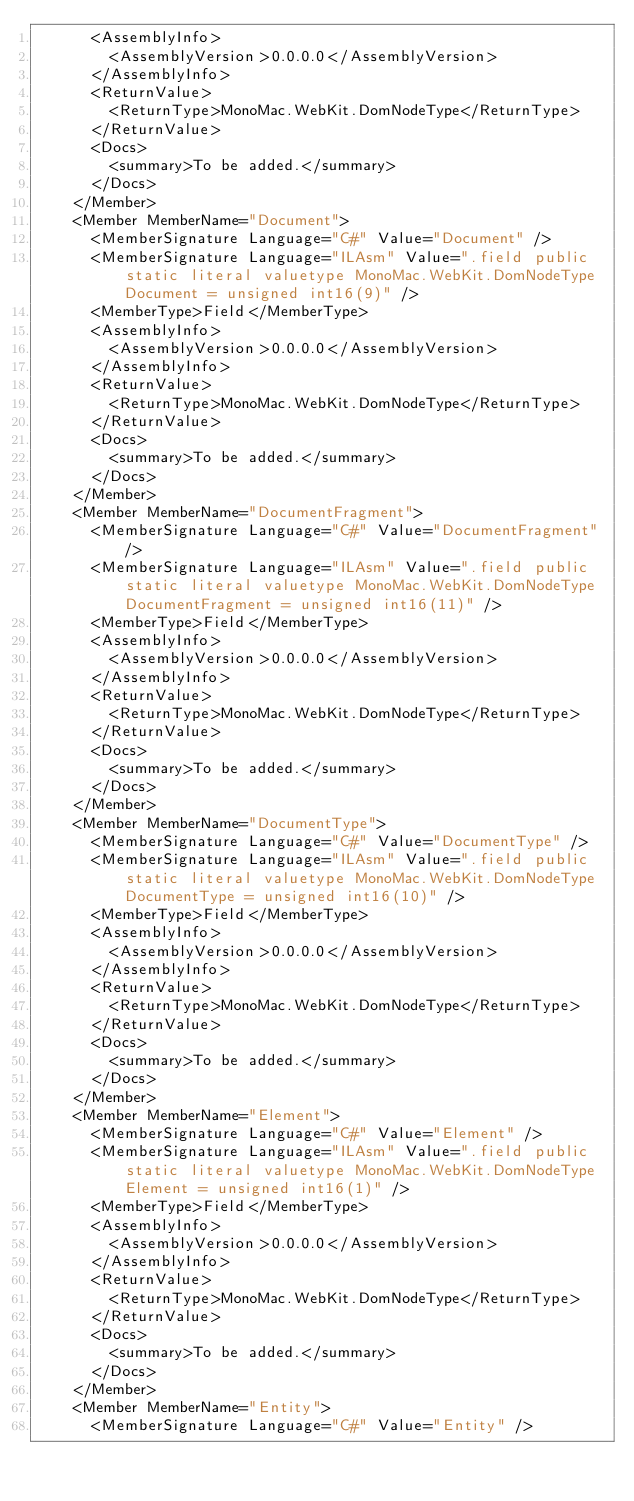<code> <loc_0><loc_0><loc_500><loc_500><_XML_>      <AssemblyInfo>
        <AssemblyVersion>0.0.0.0</AssemblyVersion>
      </AssemblyInfo>
      <ReturnValue>
        <ReturnType>MonoMac.WebKit.DomNodeType</ReturnType>
      </ReturnValue>
      <Docs>
        <summary>To be added.</summary>
      </Docs>
    </Member>
    <Member MemberName="Document">
      <MemberSignature Language="C#" Value="Document" />
      <MemberSignature Language="ILAsm" Value=".field public static literal valuetype MonoMac.WebKit.DomNodeType Document = unsigned int16(9)" />
      <MemberType>Field</MemberType>
      <AssemblyInfo>
        <AssemblyVersion>0.0.0.0</AssemblyVersion>
      </AssemblyInfo>
      <ReturnValue>
        <ReturnType>MonoMac.WebKit.DomNodeType</ReturnType>
      </ReturnValue>
      <Docs>
        <summary>To be added.</summary>
      </Docs>
    </Member>
    <Member MemberName="DocumentFragment">
      <MemberSignature Language="C#" Value="DocumentFragment" />
      <MemberSignature Language="ILAsm" Value=".field public static literal valuetype MonoMac.WebKit.DomNodeType DocumentFragment = unsigned int16(11)" />
      <MemberType>Field</MemberType>
      <AssemblyInfo>
        <AssemblyVersion>0.0.0.0</AssemblyVersion>
      </AssemblyInfo>
      <ReturnValue>
        <ReturnType>MonoMac.WebKit.DomNodeType</ReturnType>
      </ReturnValue>
      <Docs>
        <summary>To be added.</summary>
      </Docs>
    </Member>
    <Member MemberName="DocumentType">
      <MemberSignature Language="C#" Value="DocumentType" />
      <MemberSignature Language="ILAsm" Value=".field public static literal valuetype MonoMac.WebKit.DomNodeType DocumentType = unsigned int16(10)" />
      <MemberType>Field</MemberType>
      <AssemblyInfo>
        <AssemblyVersion>0.0.0.0</AssemblyVersion>
      </AssemblyInfo>
      <ReturnValue>
        <ReturnType>MonoMac.WebKit.DomNodeType</ReturnType>
      </ReturnValue>
      <Docs>
        <summary>To be added.</summary>
      </Docs>
    </Member>
    <Member MemberName="Element">
      <MemberSignature Language="C#" Value="Element" />
      <MemberSignature Language="ILAsm" Value=".field public static literal valuetype MonoMac.WebKit.DomNodeType Element = unsigned int16(1)" />
      <MemberType>Field</MemberType>
      <AssemblyInfo>
        <AssemblyVersion>0.0.0.0</AssemblyVersion>
      </AssemblyInfo>
      <ReturnValue>
        <ReturnType>MonoMac.WebKit.DomNodeType</ReturnType>
      </ReturnValue>
      <Docs>
        <summary>To be added.</summary>
      </Docs>
    </Member>
    <Member MemberName="Entity">
      <MemberSignature Language="C#" Value="Entity" /></code> 